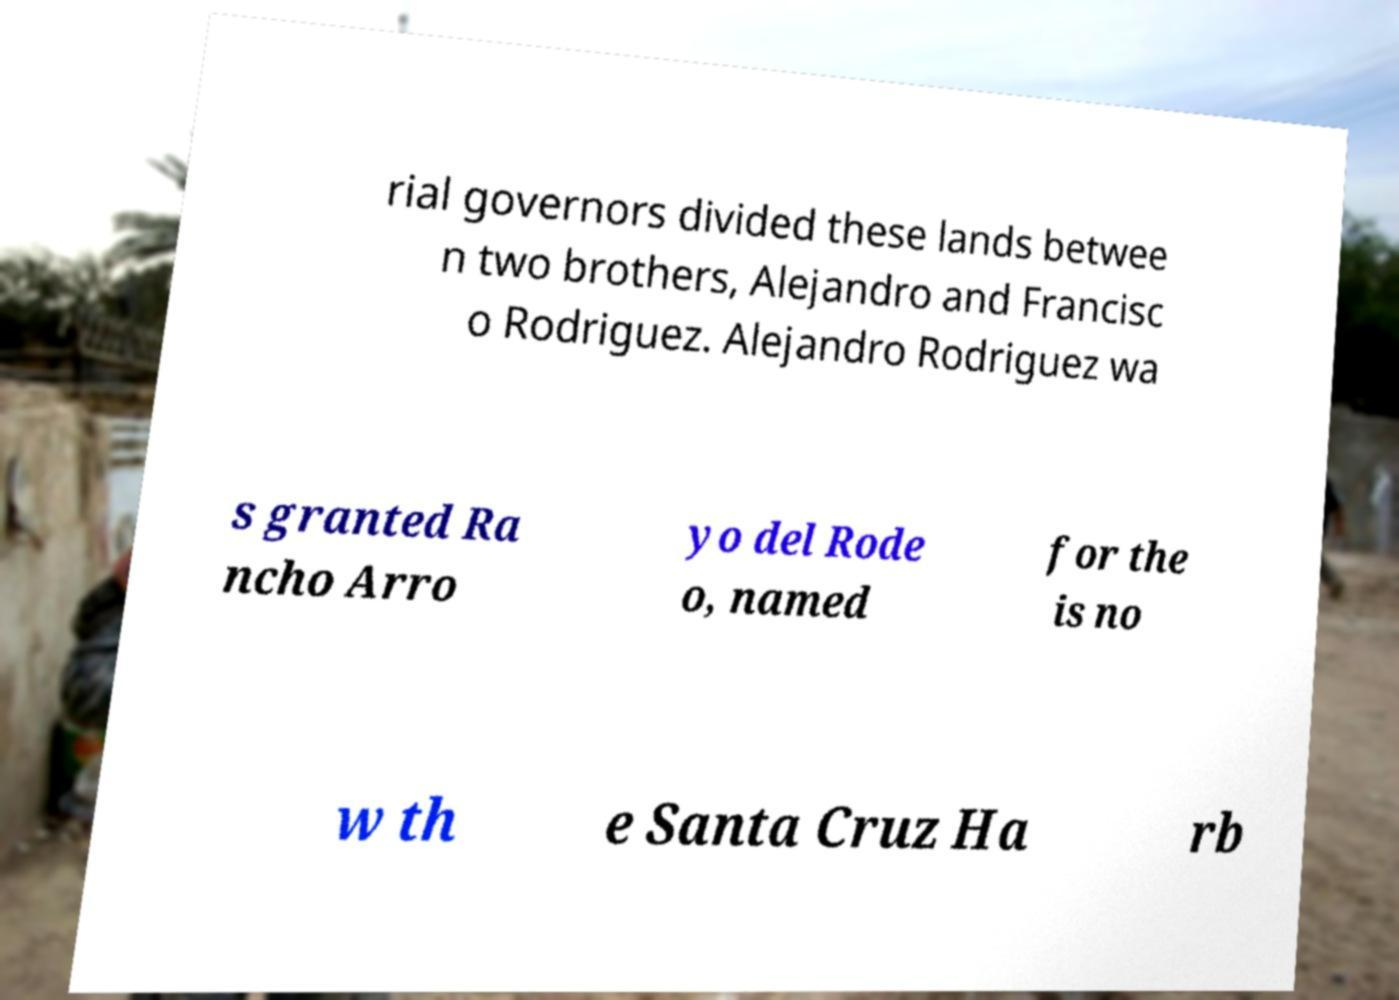Please read and relay the text visible in this image. What does it say? rial governors divided these lands betwee n two brothers, Alejandro and Francisc o Rodriguez. Alejandro Rodriguez wa s granted Ra ncho Arro yo del Rode o, named for the is no w th e Santa Cruz Ha rb 